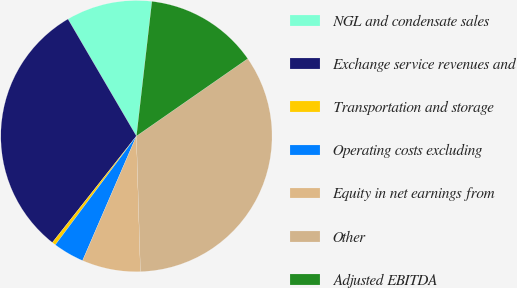<chart> <loc_0><loc_0><loc_500><loc_500><pie_chart><fcel>NGL and condensate sales<fcel>Exchange service revenues and<fcel>Transportation and storage<fcel>Operating costs excluding<fcel>Equity in net earnings from<fcel>Other<fcel>Adjusted EBITDA<nl><fcel>10.24%<fcel>30.94%<fcel>0.44%<fcel>3.7%<fcel>6.97%<fcel>34.2%<fcel>13.51%<nl></chart> 